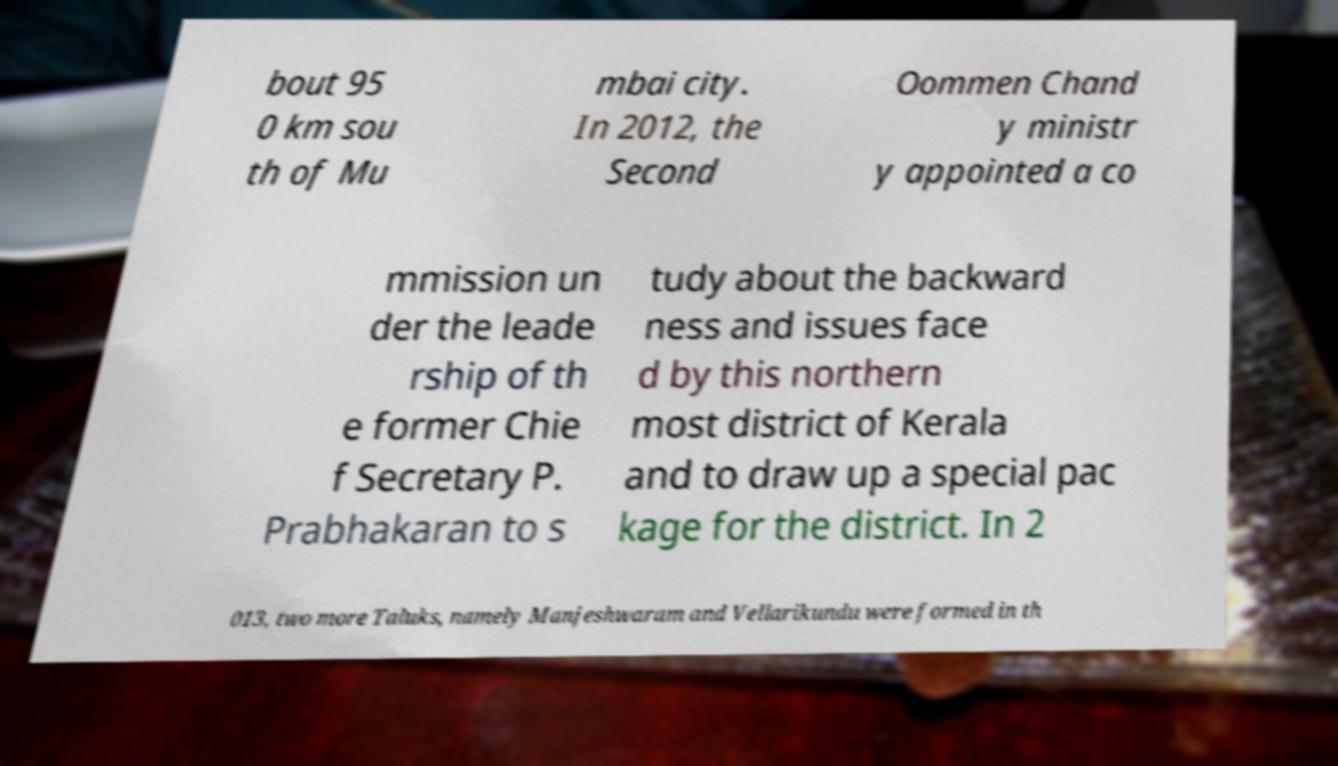Please identify and transcribe the text found in this image. bout 95 0 km sou th of Mu mbai city. In 2012, the Second Oommen Chand y ministr y appointed a co mmission un der the leade rship of th e former Chie f Secretary P. Prabhakaran to s tudy about the backward ness and issues face d by this northern most district of Kerala and to draw up a special pac kage for the district. In 2 013, two more Taluks, namely Manjeshwaram and Vellarikundu were formed in th 